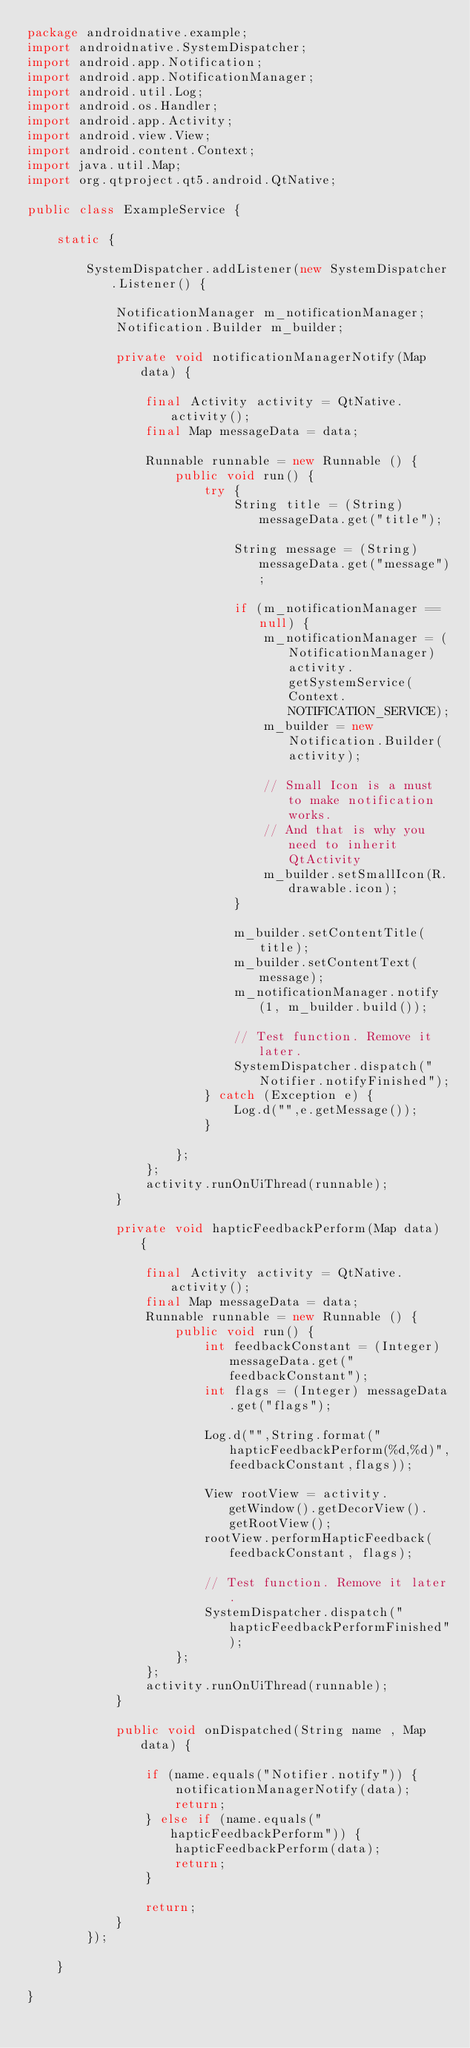Convert code to text. <code><loc_0><loc_0><loc_500><loc_500><_Java_>package androidnative.example;
import androidnative.SystemDispatcher;
import android.app.Notification;
import android.app.NotificationManager;
import android.util.Log;
import android.os.Handler;
import android.app.Activity;
import android.view.View;
import android.content.Context;
import java.util.Map;
import org.qtproject.qt5.android.QtNative;

public class ExampleService {

    static {

        SystemDispatcher.addListener(new SystemDispatcher.Listener() {

            NotificationManager m_notificationManager;
            Notification.Builder m_builder;

            private void notificationManagerNotify(Map data) {

                final Activity activity = QtNative.activity();
                final Map messageData = data;

                Runnable runnable = new Runnable () {
                    public void run() {
                        try {
                            String title = (String) messageData.get("title");

                            String message = (String) messageData.get("message");

                            if (m_notificationManager == null) {
                                m_notificationManager = (NotificationManager) activity.getSystemService(Context.NOTIFICATION_SERVICE);
                                m_builder = new Notification.Builder(activity);

                                // Small Icon is a must to make notification works.
                                // And that is why you need to inherit QtActivity
                                m_builder.setSmallIcon(R.drawable.icon);
                            }

                            m_builder.setContentTitle(title);
                            m_builder.setContentText(message);
                            m_notificationManager.notify(1, m_builder.build());

                            // Test function. Remove it later.
                            SystemDispatcher.dispatch("Notifier.notifyFinished");
                        } catch (Exception e) {
                            Log.d("",e.getMessage());
                        }

                    };
                };
                activity.runOnUiThread(runnable);
            }

            private void hapticFeedbackPerform(Map data) {

                final Activity activity = QtNative.activity();
                final Map messageData = data;
                Runnable runnable = new Runnable () {
                    public void run() {
                        int feedbackConstant = (Integer) messageData.get("feedbackConstant");
                        int flags = (Integer) messageData.get("flags");

                        Log.d("",String.format("hapticFeedbackPerform(%d,%d)",feedbackConstant,flags));

                        View rootView = activity.getWindow().getDecorView().getRootView();
                        rootView.performHapticFeedback(feedbackConstant, flags);

                        // Test function. Remove it later.
                        SystemDispatcher.dispatch("hapticFeedbackPerformFinished");
                    };
                };
                activity.runOnUiThread(runnable);
            }

            public void onDispatched(String name , Map data) {

                if (name.equals("Notifier.notify")) {
                    notificationManagerNotify(data);
                    return;
                } else if (name.equals("hapticFeedbackPerform")) {
                    hapticFeedbackPerform(data);
                    return;
                }

                return;
            }
        });

    }

}

</code> 